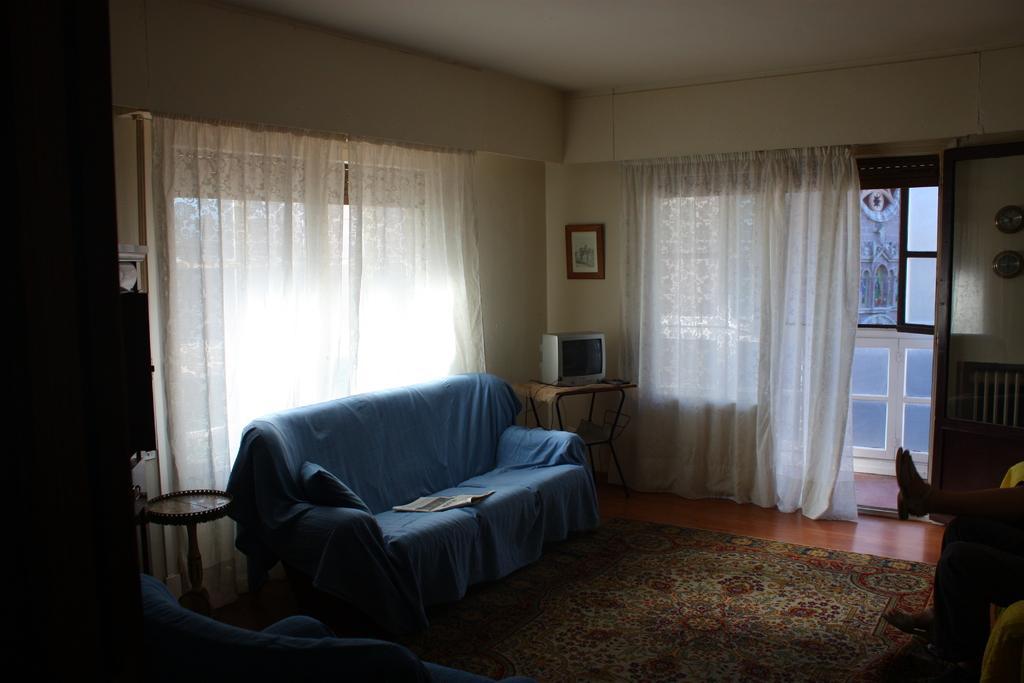How would you summarize this image in a sentence or two? This is a picture of a room. On the right there is a person seated. In the center of the image there is a couch, desk, on the desk there is a television. In this room in the background there are windows, curtains. The wall is painted in white. On the wall there is a frame. On the left there is a table. 